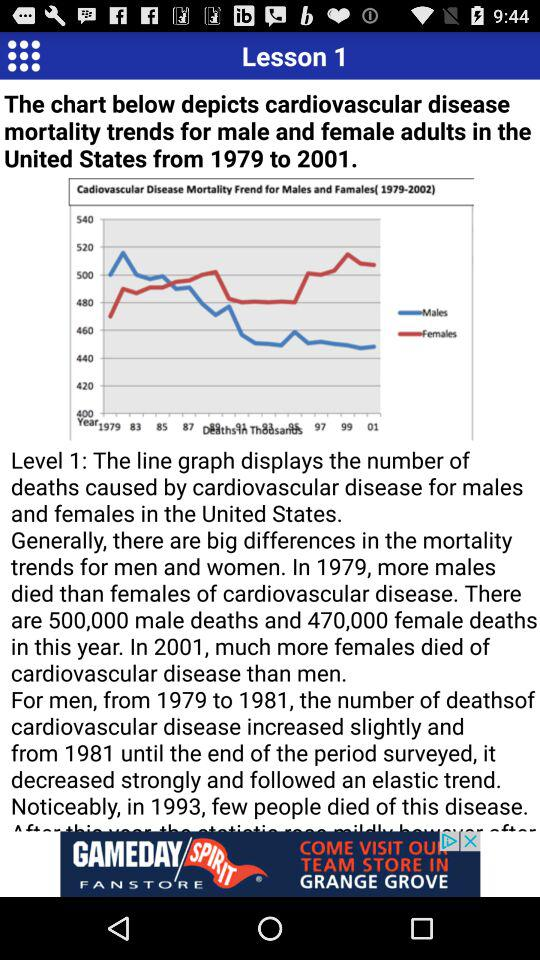What is the number of female deaths in the years from 1995?
When the provided information is insufficient, respond with <no answer>. <no answer> 